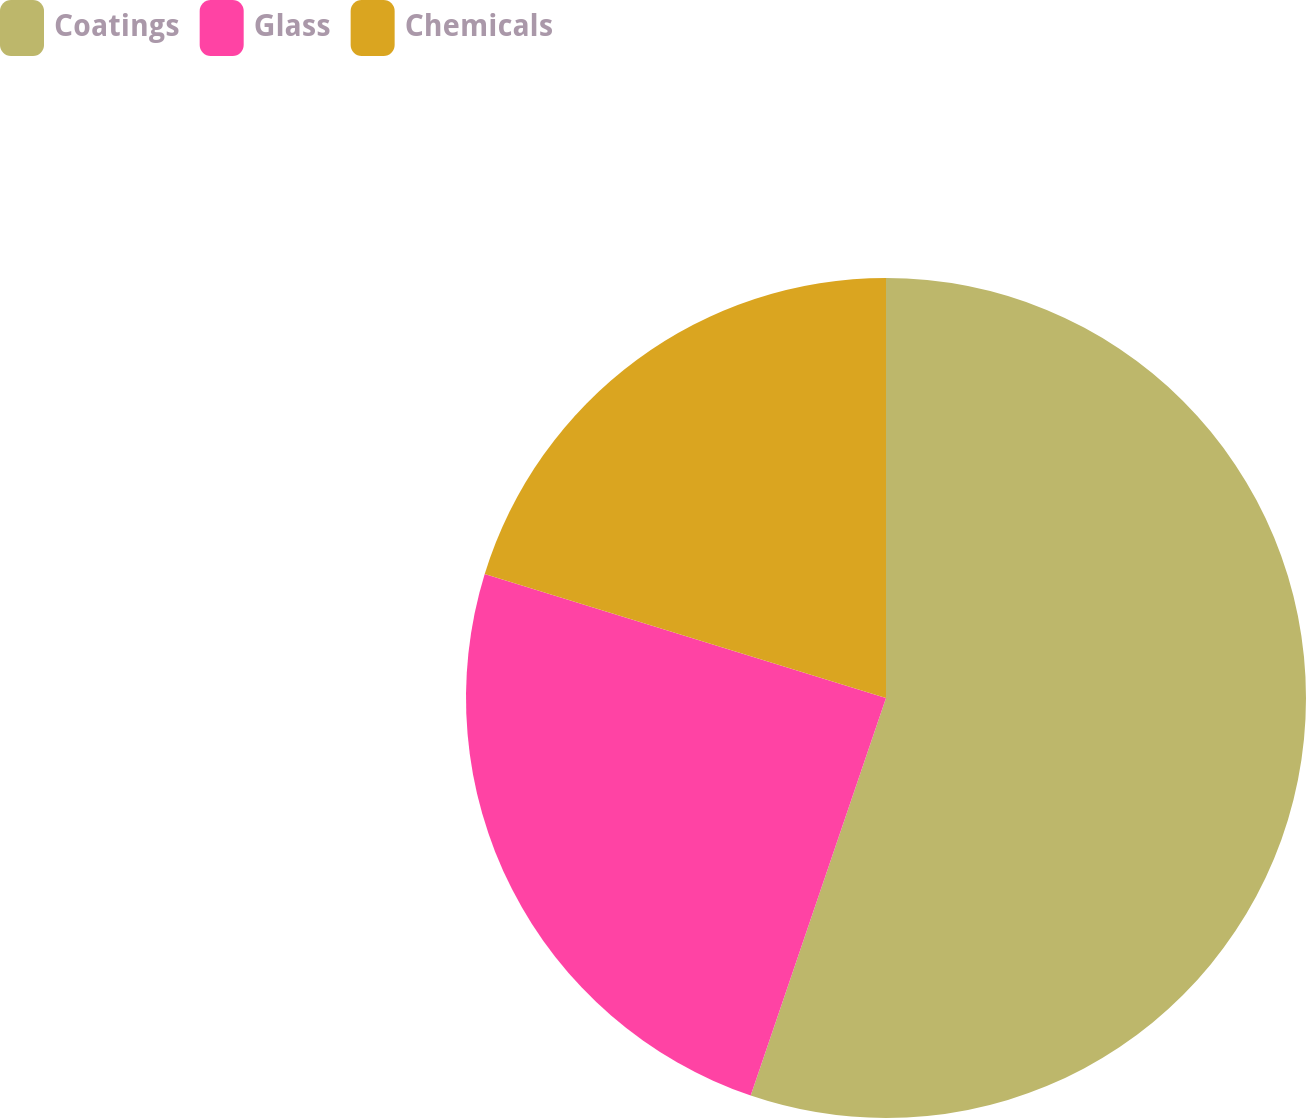Convert chart. <chart><loc_0><loc_0><loc_500><loc_500><pie_chart><fcel>Coatings<fcel>Glass<fcel>Chemicals<nl><fcel>55.22%<fcel>24.55%<fcel>20.23%<nl></chart> 